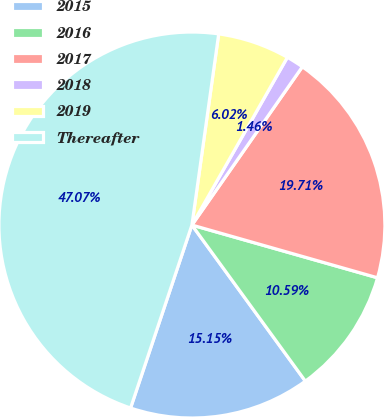Convert chart. <chart><loc_0><loc_0><loc_500><loc_500><pie_chart><fcel>2015<fcel>2016<fcel>2017<fcel>2018<fcel>2019<fcel>Thereafter<nl><fcel>15.15%<fcel>10.59%<fcel>19.71%<fcel>1.46%<fcel>6.02%<fcel>47.07%<nl></chart> 